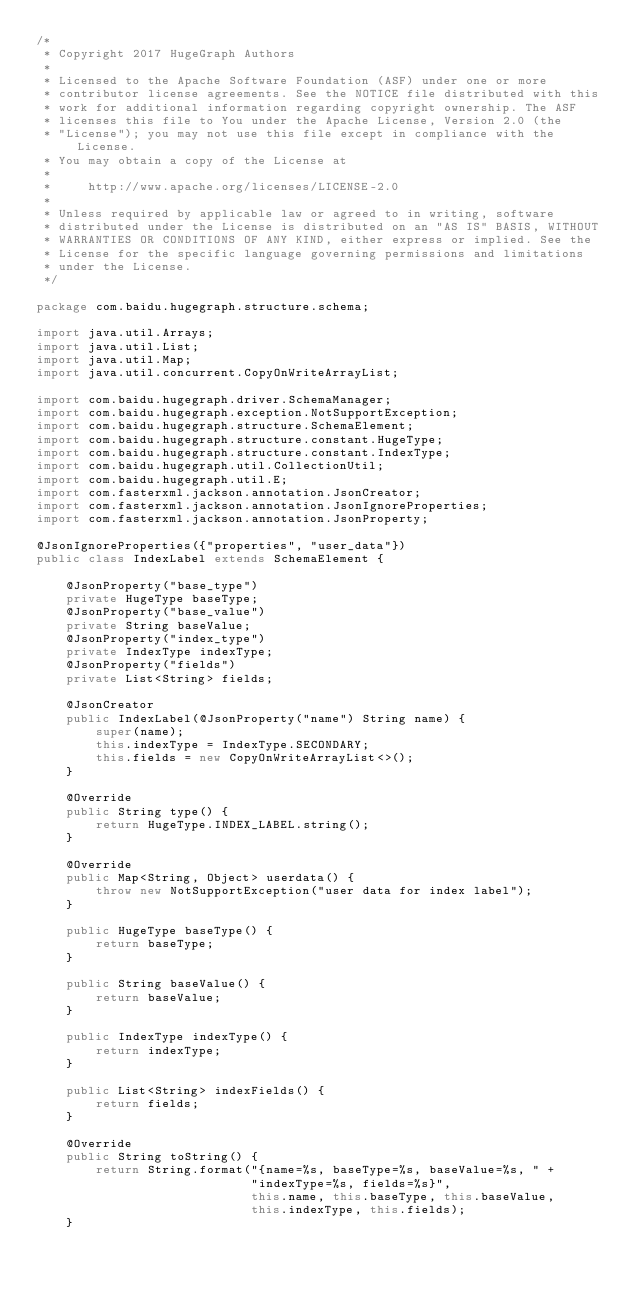Convert code to text. <code><loc_0><loc_0><loc_500><loc_500><_Java_>/*
 * Copyright 2017 HugeGraph Authors
 *
 * Licensed to the Apache Software Foundation (ASF) under one or more
 * contributor license agreements. See the NOTICE file distributed with this
 * work for additional information regarding copyright ownership. The ASF
 * licenses this file to You under the Apache License, Version 2.0 (the
 * "License"); you may not use this file except in compliance with the License.
 * You may obtain a copy of the License at
 *
 *     http://www.apache.org/licenses/LICENSE-2.0
 *
 * Unless required by applicable law or agreed to in writing, software
 * distributed under the License is distributed on an "AS IS" BASIS, WITHOUT
 * WARRANTIES OR CONDITIONS OF ANY KIND, either express or implied. See the
 * License for the specific language governing permissions and limitations
 * under the License.
 */

package com.baidu.hugegraph.structure.schema;

import java.util.Arrays;
import java.util.List;
import java.util.Map;
import java.util.concurrent.CopyOnWriteArrayList;

import com.baidu.hugegraph.driver.SchemaManager;
import com.baidu.hugegraph.exception.NotSupportException;
import com.baidu.hugegraph.structure.SchemaElement;
import com.baidu.hugegraph.structure.constant.HugeType;
import com.baidu.hugegraph.structure.constant.IndexType;
import com.baidu.hugegraph.util.CollectionUtil;
import com.baidu.hugegraph.util.E;
import com.fasterxml.jackson.annotation.JsonCreator;
import com.fasterxml.jackson.annotation.JsonIgnoreProperties;
import com.fasterxml.jackson.annotation.JsonProperty;

@JsonIgnoreProperties({"properties", "user_data"})
public class IndexLabel extends SchemaElement {

    @JsonProperty("base_type")
    private HugeType baseType;
    @JsonProperty("base_value")
    private String baseValue;
    @JsonProperty("index_type")
    private IndexType indexType;
    @JsonProperty("fields")
    private List<String> fields;

    @JsonCreator
    public IndexLabel(@JsonProperty("name") String name) {
        super(name);
        this.indexType = IndexType.SECONDARY;
        this.fields = new CopyOnWriteArrayList<>();
    }

    @Override
    public String type() {
        return HugeType.INDEX_LABEL.string();
    }

    @Override
    public Map<String, Object> userdata() {
        throw new NotSupportException("user data for index label");
    }

    public HugeType baseType() {
        return baseType;
    }

    public String baseValue() {
        return baseValue;
    }

    public IndexType indexType() {
        return indexType;
    }

    public List<String> indexFields() {
        return fields;
    }

    @Override
    public String toString() {
        return String.format("{name=%s, baseType=%s, baseValue=%s, " +
                             "indexType=%s, fields=%s}",
                             this.name, this.baseType, this.baseValue,
                             this.indexType, this.fields);
    }
</code> 